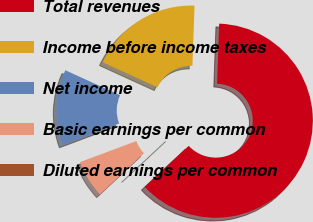Convert chart to OTSL. <chart><loc_0><loc_0><loc_500><loc_500><pie_chart><fcel>Total revenues<fcel>Income before income taxes<fcel>Net income<fcel>Basic earnings per common<fcel>Diluted earnings per common<nl><fcel>62.5%<fcel>18.75%<fcel>12.5%<fcel>6.25%<fcel>0.0%<nl></chart> 